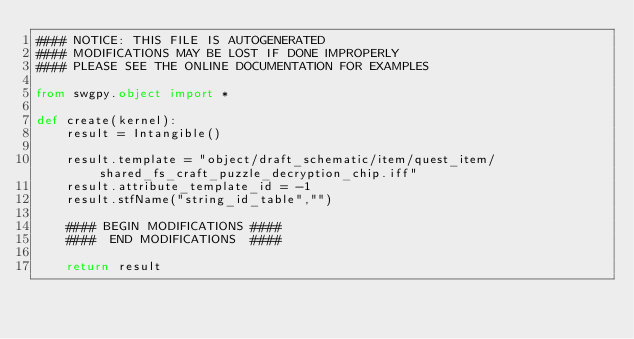Convert code to text. <code><loc_0><loc_0><loc_500><loc_500><_Python_>#### NOTICE: THIS FILE IS AUTOGENERATED
#### MODIFICATIONS MAY BE LOST IF DONE IMPROPERLY
#### PLEASE SEE THE ONLINE DOCUMENTATION FOR EXAMPLES

from swgpy.object import *	

def create(kernel):
	result = Intangible()

	result.template = "object/draft_schematic/item/quest_item/shared_fs_craft_puzzle_decryption_chip.iff"
	result.attribute_template_id = -1
	result.stfName("string_id_table","")		
	
	#### BEGIN MODIFICATIONS ####
	####  END MODIFICATIONS  ####
	
	return result</code> 